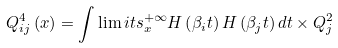<formula> <loc_0><loc_0><loc_500><loc_500>Q _ { i j } ^ { 4 } \left ( x \right ) = \int \lim i t s _ { x } ^ { + \infty } { H \left ( { \beta _ { i } t } \right ) H \left ( { \beta _ { j } t } \right ) d t \times Q _ { j } ^ { 2 } }</formula> 